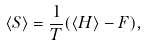Convert formula to latex. <formula><loc_0><loc_0><loc_500><loc_500>\left \langle S \right \rangle = \frac { 1 } { T } ( \left \langle H \right \rangle - F ) ,</formula> 